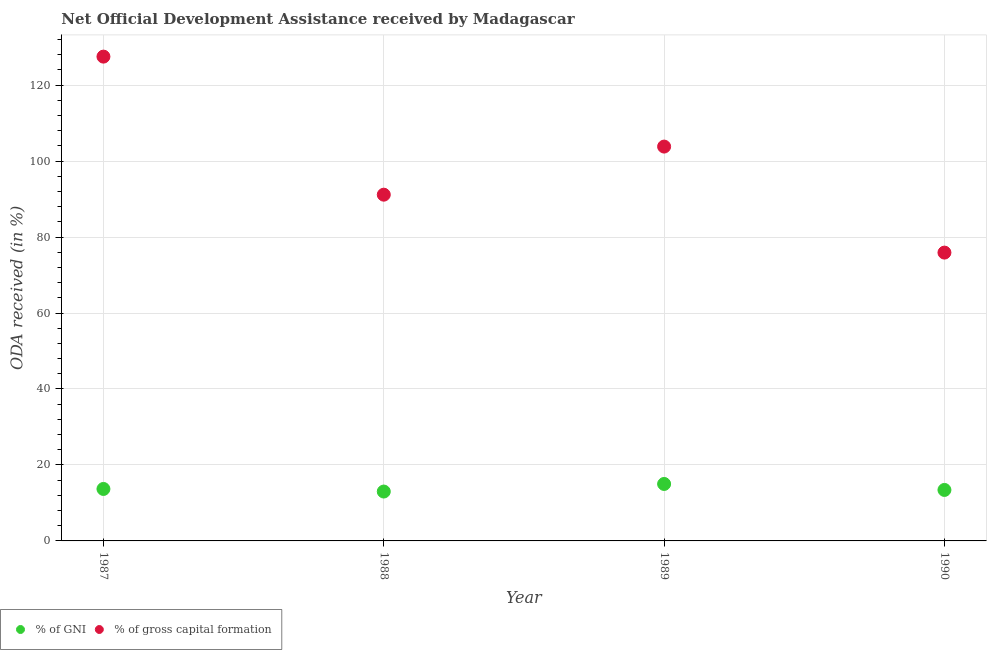Is the number of dotlines equal to the number of legend labels?
Offer a terse response. Yes. What is the oda received as percentage of gni in 1988?
Ensure brevity in your answer.  13. Across all years, what is the maximum oda received as percentage of gross capital formation?
Your answer should be compact. 127.49. Across all years, what is the minimum oda received as percentage of gross capital formation?
Offer a very short reply. 75.9. In which year was the oda received as percentage of gross capital formation minimum?
Your answer should be very brief. 1990. What is the total oda received as percentage of gni in the graph?
Offer a terse response. 55.1. What is the difference between the oda received as percentage of gross capital formation in 1987 and that in 1989?
Provide a succinct answer. 23.68. What is the difference between the oda received as percentage of gross capital formation in 1987 and the oda received as percentage of gni in 1990?
Give a very brief answer. 114.07. What is the average oda received as percentage of gross capital formation per year?
Your response must be concise. 99.59. In the year 1988, what is the difference between the oda received as percentage of gni and oda received as percentage of gross capital formation?
Your answer should be compact. -78.15. What is the ratio of the oda received as percentage of gni in 1988 to that in 1990?
Make the answer very short. 0.97. Is the oda received as percentage of gni in 1987 less than that in 1988?
Ensure brevity in your answer.  No. What is the difference between the highest and the second highest oda received as percentage of gross capital formation?
Give a very brief answer. 23.68. What is the difference between the highest and the lowest oda received as percentage of gni?
Keep it short and to the point. 2. In how many years, is the oda received as percentage of gni greater than the average oda received as percentage of gni taken over all years?
Offer a terse response. 1. Does the oda received as percentage of gni monotonically increase over the years?
Your response must be concise. No. Is the oda received as percentage of gross capital formation strictly less than the oda received as percentage of gni over the years?
Offer a very short reply. No. How many dotlines are there?
Provide a short and direct response. 2. Are the values on the major ticks of Y-axis written in scientific E-notation?
Make the answer very short. No. Where does the legend appear in the graph?
Offer a terse response. Bottom left. How many legend labels are there?
Your answer should be very brief. 2. How are the legend labels stacked?
Keep it short and to the point. Horizontal. What is the title of the graph?
Ensure brevity in your answer.  Net Official Development Assistance received by Madagascar. Does "Female labor force" appear as one of the legend labels in the graph?
Provide a short and direct response. No. What is the label or title of the Y-axis?
Your answer should be very brief. ODA received (in %). What is the ODA received (in %) of % of GNI in 1987?
Your response must be concise. 13.68. What is the ODA received (in %) in % of gross capital formation in 1987?
Give a very brief answer. 127.49. What is the ODA received (in %) in % of GNI in 1988?
Your response must be concise. 13. What is the ODA received (in %) of % of gross capital formation in 1988?
Offer a terse response. 91.15. What is the ODA received (in %) of % of GNI in 1989?
Make the answer very short. 15. What is the ODA received (in %) of % of gross capital formation in 1989?
Provide a succinct answer. 103.81. What is the ODA received (in %) of % of GNI in 1990?
Provide a succinct answer. 13.42. What is the ODA received (in %) in % of gross capital formation in 1990?
Your response must be concise. 75.9. Across all years, what is the maximum ODA received (in %) in % of GNI?
Your answer should be compact. 15. Across all years, what is the maximum ODA received (in %) of % of gross capital formation?
Offer a very short reply. 127.49. Across all years, what is the minimum ODA received (in %) of % of GNI?
Your answer should be compact. 13. Across all years, what is the minimum ODA received (in %) of % of gross capital formation?
Offer a terse response. 75.9. What is the total ODA received (in %) of % of GNI in the graph?
Offer a terse response. 55.1. What is the total ODA received (in %) of % of gross capital formation in the graph?
Offer a very short reply. 398.36. What is the difference between the ODA received (in %) in % of GNI in 1987 and that in 1988?
Offer a very short reply. 0.68. What is the difference between the ODA received (in %) of % of gross capital formation in 1987 and that in 1988?
Give a very brief answer. 36.34. What is the difference between the ODA received (in %) in % of GNI in 1987 and that in 1989?
Ensure brevity in your answer.  -1.32. What is the difference between the ODA received (in %) in % of gross capital formation in 1987 and that in 1989?
Make the answer very short. 23.68. What is the difference between the ODA received (in %) of % of GNI in 1987 and that in 1990?
Your answer should be compact. 0.26. What is the difference between the ODA received (in %) in % of gross capital formation in 1987 and that in 1990?
Offer a terse response. 51.59. What is the difference between the ODA received (in %) of % of GNI in 1988 and that in 1989?
Ensure brevity in your answer.  -2. What is the difference between the ODA received (in %) in % of gross capital formation in 1988 and that in 1989?
Your answer should be compact. -12.66. What is the difference between the ODA received (in %) of % of GNI in 1988 and that in 1990?
Provide a succinct answer. -0.42. What is the difference between the ODA received (in %) of % of gross capital formation in 1988 and that in 1990?
Your answer should be compact. 15.25. What is the difference between the ODA received (in %) in % of GNI in 1989 and that in 1990?
Your answer should be very brief. 1.58. What is the difference between the ODA received (in %) of % of gross capital formation in 1989 and that in 1990?
Keep it short and to the point. 27.91. What is the difference between the ODA received (in %) in % of GNI in 1987 and the ODA received (in %) in % of gross capital formation in 1988?
Your answer should be compact. -77.47. What is the difference between the ODA received (in %) of % of GNI in 1987 and the ODA received (in %) of % of gross capital formation in 1989?
Your answer should be compact. -90.13. What is the difference between the ODA received (in %) in % of GNI in 1987 and the ODA received (in %) in % of gross capital formation in 1990?
Keep it short and to the point. -62.22. What is the difference between the ODA received (in %) in % of GNI in 1988 and the ODA received (in %) in % of gross capital formation in 1989?
Offer a very short reply. -90.81. What is the difference between the ODA received (in %) of % of GNI in 1988 and the ODA received (in %) of % of gross capital formation in 1990?
Offer a very short reply. -62.9. What is the difference between the ODA received (in %) in % of GNI in 1989 and the ODA received (in %) in % of gross capital formation in 1990?
Your answer should be compact. -60.91. What is the average ODA received (in %) of % of GNI per year?
Give a very brief answer. 13.77. What is the average ODA received (in %) in % of gross capital formation per year?
Offer a very short reply. 99.59. In the year 1987, what is the difference between the ODA received (in %) of % of GNI and ODA received (in %) of % of gross capital formation?
Your answer should be compact. -113.81. In the year 1988, what is the difference between the ODA received (in %) of % of GNI and ODA received (in %) of % of gross capital formation?
Your response must be concise. -78.15. In the year 1989, what is the difference between the ODA received (in %) in % of GNI and ODA received (in %) in % of gross capital formation?
Provide a succinct answer. -88.82. In the year 1990, what is the difference between the ODA received (in %) in % of GNI and ODA received (in %) in % of gross capital formation?
Ensure brevity in your answer.  -62.48. What is the ratio of the ODA received (in %) in % of GNI in 1987 to that in 1988?
Your answer should be very brief. 1.05. What is the ratio of the ODA received (in %) in % of gross capital formation in 1987 to that in 1988?
Provide a succinct answer. 1.4. What is the ratio of the ODA received (in %) in % of GNI in 1987 to that in 1989?
Offer a very short reply. 0.91. What is the ratio of the ODA received (in %) in % of gross capital formation in 1987 to that in 1989?
Give a very brief answer. 1.23. What is the ratio of the ODA received (in %) in % of GNI in 1987 to that in 1990?
Give a very brief answer. 1.02. What is the ratio of the ODA received (in %) in % of gross capital formation in 1987 to that in 1990?
Your response must be concise. 1.68. What is the ratio of the ODA received (in %) of % of GNI in 1988 to that in 1989?
Your response must be concise. 0.87. What is the ratio of the ODA received (in %) in % of gross capital formation in 1988 to that in 1989?
Ensure brevity in your answer.  0.88. What is the ratio of the ODA received (in %) in % of GNI in 1988 to that in 1990?
Provide a succinct answer. 0.97. What is the ratio of the ODA received (in %) in % of gross capital formation in 1988 to that in 1990?
Your answer should be compact. 1.2. What is the ratio of the ODA received (in %) of % of GNI in 1989 to that in 1990?
Your response must be concise. 1.12. What is the ratio of the ODA received (in %) of % of gross capital formation in 1989 to that in 1990?
Your answer should be compact. 1.37. What is the difference between the highest and the second highest ODA received (in %) of % of GNI?
Offer a terse response. 1.32. What is the difference between the highest and the second highest ODA received (in %) in % of gross capital formation?
Provide a succinct answer. 23.68. What is the difference between the highest and the lowest ODA received (in %) in % of GNI?
Your response must be concise. 2. What is the difference between the highest and the lowest ODA received (in %) in % of gross capital formation?
Ensure brevity in your answer.  51.59. 